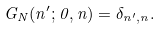<formula> <loc_0><loc_0><loc_500><loc_500>G _ { N } ( n ^ { \prime } ; 0 , n ) = \delta _ { n ^ { \prime } , n } .</formula> 